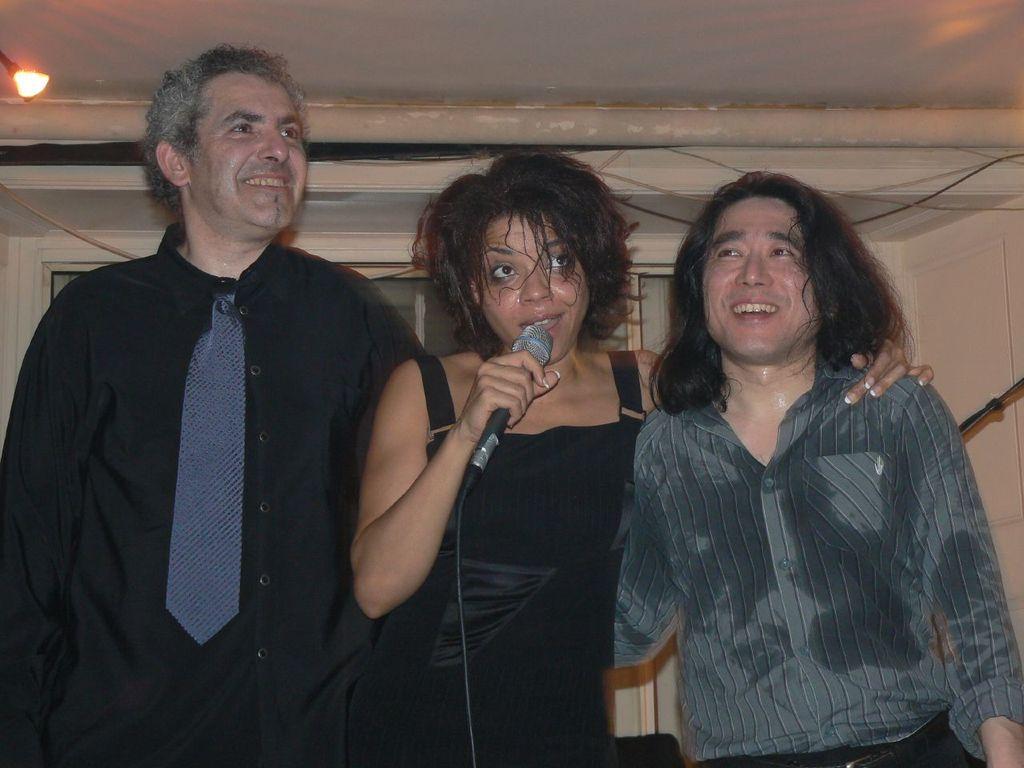How would you summarize this image in a sentence or two? In this image we can see a woman is standing and holding a mic in her hand and there are two other men. In the background we can see a light on the left side, wall, doors, cables and a pole. 